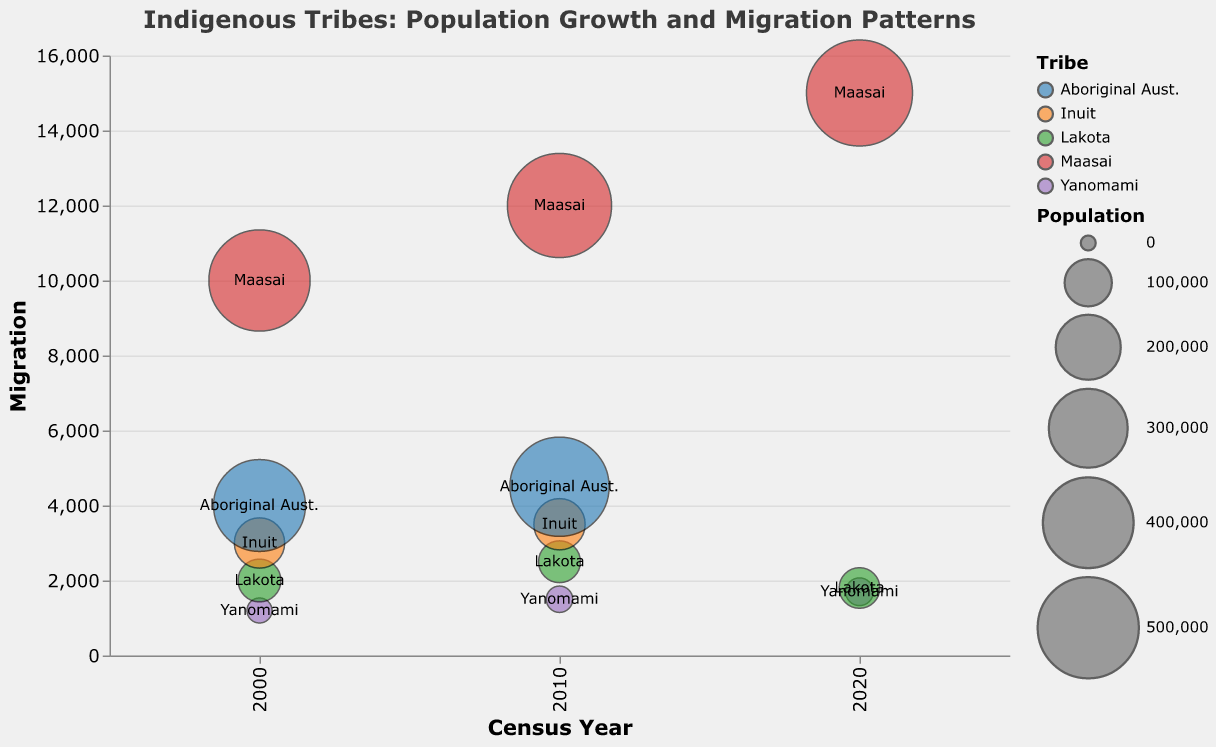What is the title of the figure? The title of the figure is displayed prominently at the top in bold, stating "Indigenous Tribes: Population Growth and Migration Patterns".
Answer: Indigenous Tribes: Population Growth and Migration Patterns Which tribe had the highest population in 2020? Observing the size of the bubbles, the Maasai tribe's bubble is the largest in 2020, indicating the highest population.
Answer: Maasai How is the migration trend for the Lakota tribe from 2000 to 2020? The migration for the Lakota tribe increased from 2000 to 2010 and then decreased in 2020.
Answer: Increased then decreased What is the relationship between population size and migration for the Yanomami tribe in 2020? Looking at the 2020 data point for the Yanomami tribe, this tribe has a population of 27,000 and migration of 1,700.
Answer: Population: 27,000, Migration: 1,700 Compare the migration values of Yanomami and Lakota tribes in the year 2010. Which tribe had more migration? Checking the migration values in the 2010 data, Yanomami had 1,500 migrations, and Lakota had 2,500 migrations. Therefore, Lakota had more migration.
Answer: Lakota What tribe's migration increased the most from 2000 to 2010? By comparing the migration values from 2000 to 2010 for each tribe, we see that the Lakota's migration increased by the most significant value (500 more in 2010 compared to 2000).
Answer: Lakota Describe the demographic details of the Maasai tribe in 2020. The tooltip provides specific demographic details for each tribe in a given year. For the Maasai tribe in 2020, it states that increased educational outreach influences the younger generations.
Answer: Increased educational outreach influencing younger generations What is the average migration value for the Yanomami tribe across all the recorded years? The migration values for the Yanomami tribe are 1,200 (2000), 1,500 (2010), and 1,700 (2020). The average is calculated as (1200 + 1500 + 1700) / 3 = 1,467.
Answer: 1,467 Which tribe showed a decrease in both population and migration between 2010 and 2020? By examining data points from 2010 to 2020, only the Lakota tribe shows a decrease in both population (76,000 to 71,000) and migration (2,500 to 1,800).
Answer: Lakota 